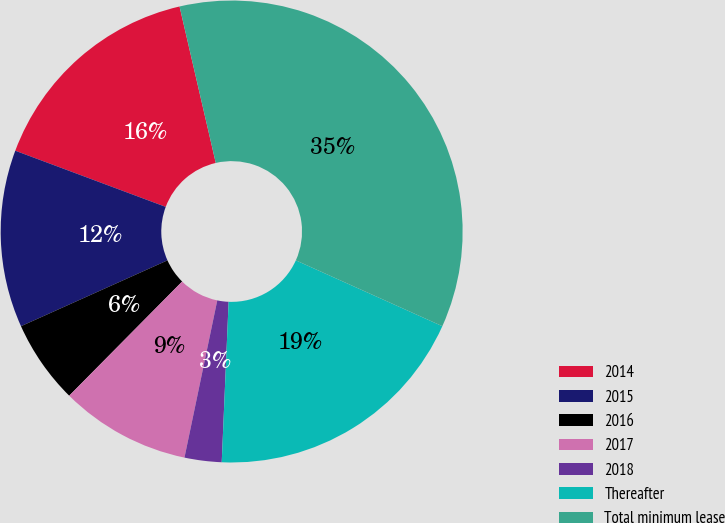Convert chart. <chart><loc_0><loc_0><loc_500><loc_500><pie_chart><fcel>2014<fcel>2015<fcel>2016<fcel>2017<fcel>2018<fcel>Thereafter<fcel>Total minimum lease<nl><fcel>15.69%<fcel>12.41%<fcel>5.86%<fcel>9.14%<fcel>2.59%<fcel>18.96%<fcel>35.34%<nl></chart> 